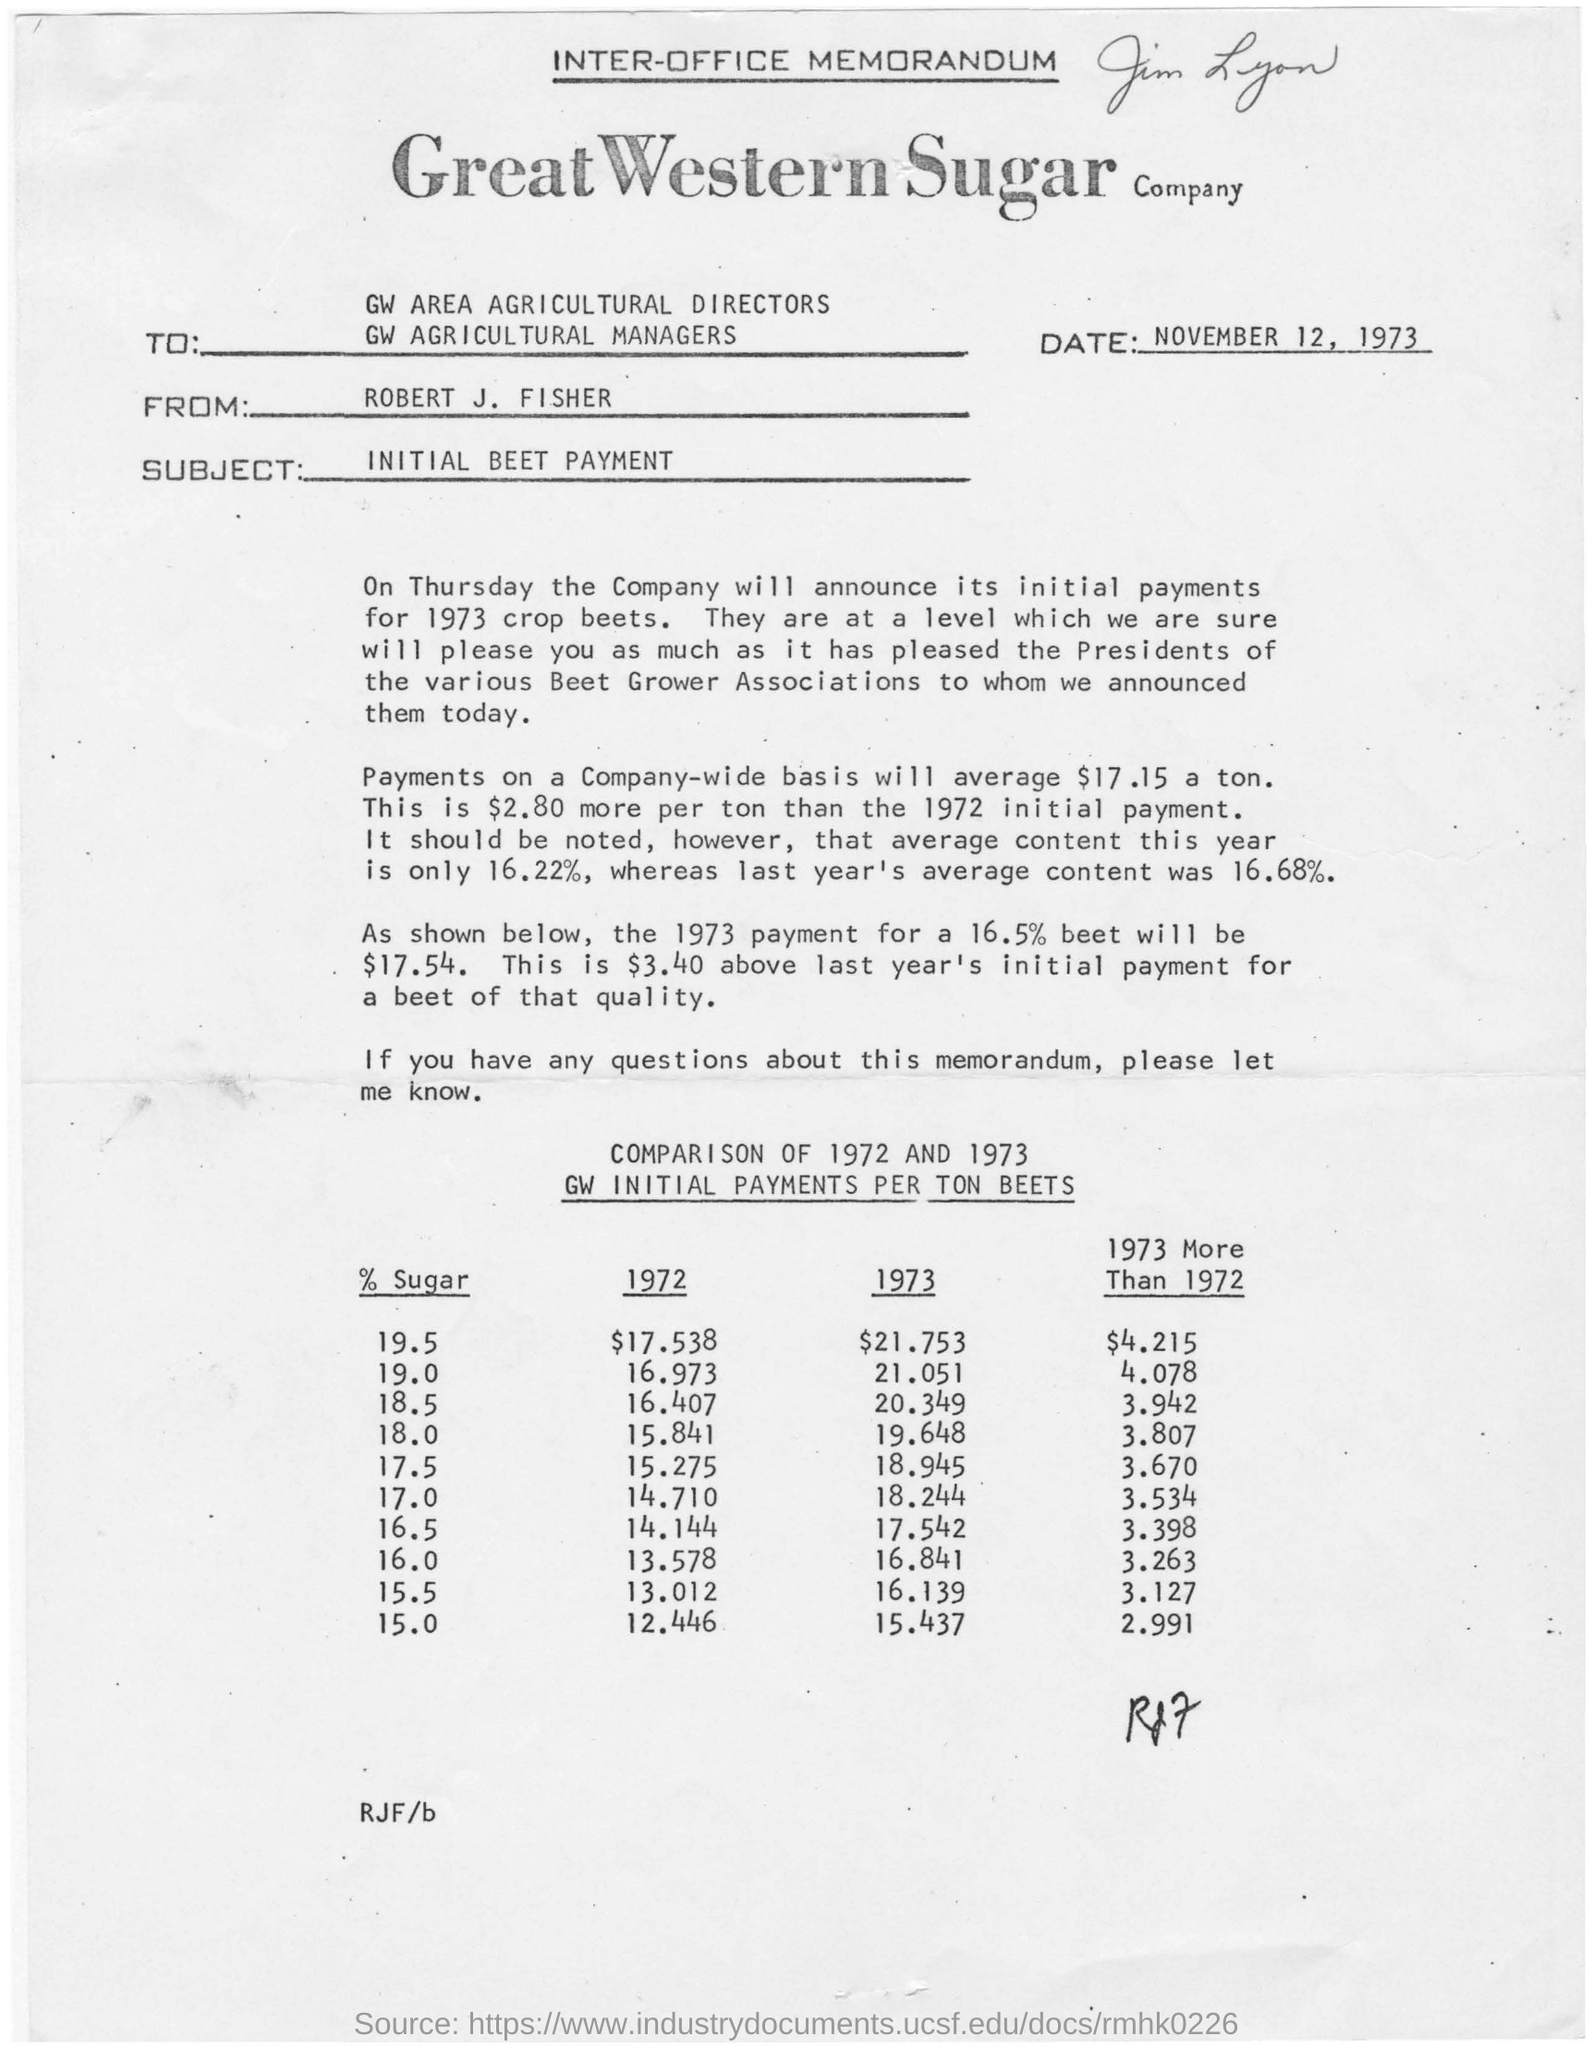Draw attention to some important aspects in this diagram. The memorandum states that the date is November 12, 1973. The memorandum is from Robert J. Fisher. 